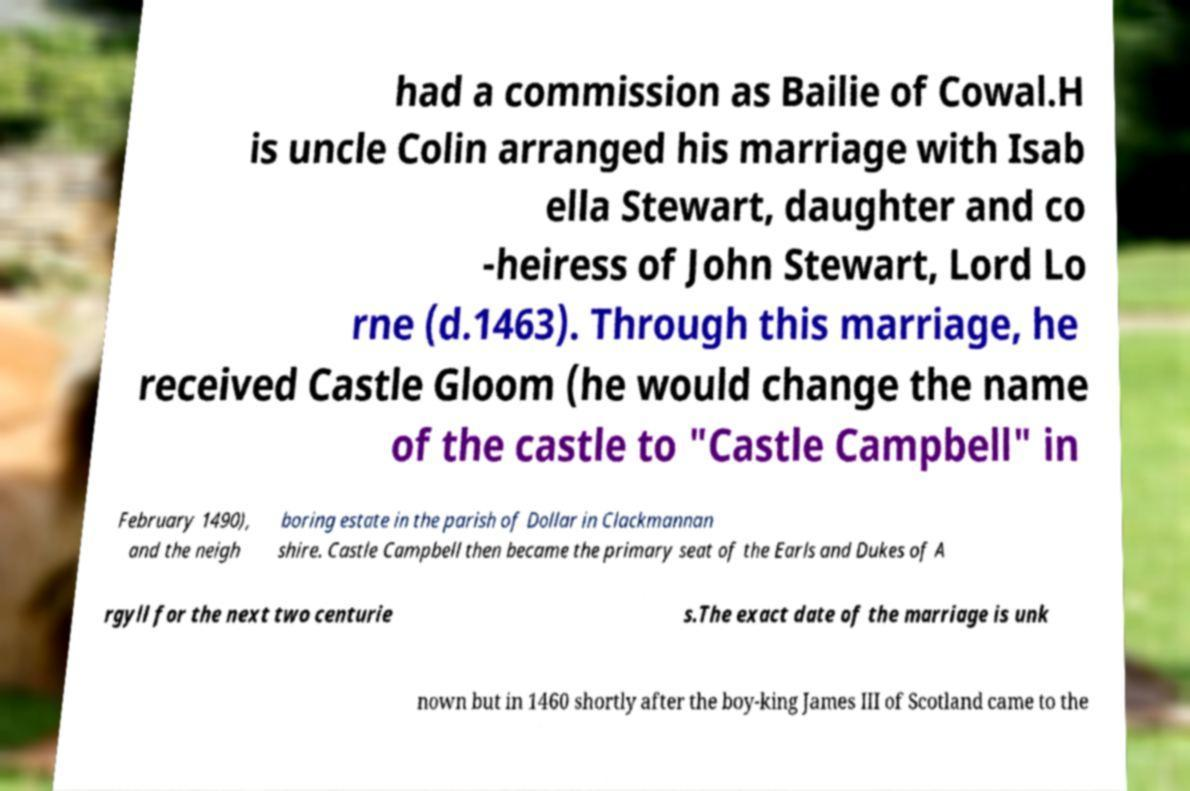Could you assist in decoding the text presented in this image and type it out clearly? had a commission as Bailie of Cowal.H is uncle Colin arranged his marriage with Isab ella Stewart, daughter and co -heiress of John Stewart, Lord Lo rne (d.1463). Through this marriage, he received Castle Gloom (he would change the name of the castle to "Castle Campbell" in February 1490), and the neigh boring estate in the parish of Dollar in Clackmannan shire. Castle Campbell then became the primary seat of the Earls and Dukes of A rgyll for the next two centurie s.The exact date of the marriage is unk nown but in 1460 shortly after the boy-king James III of Scotland came to the 